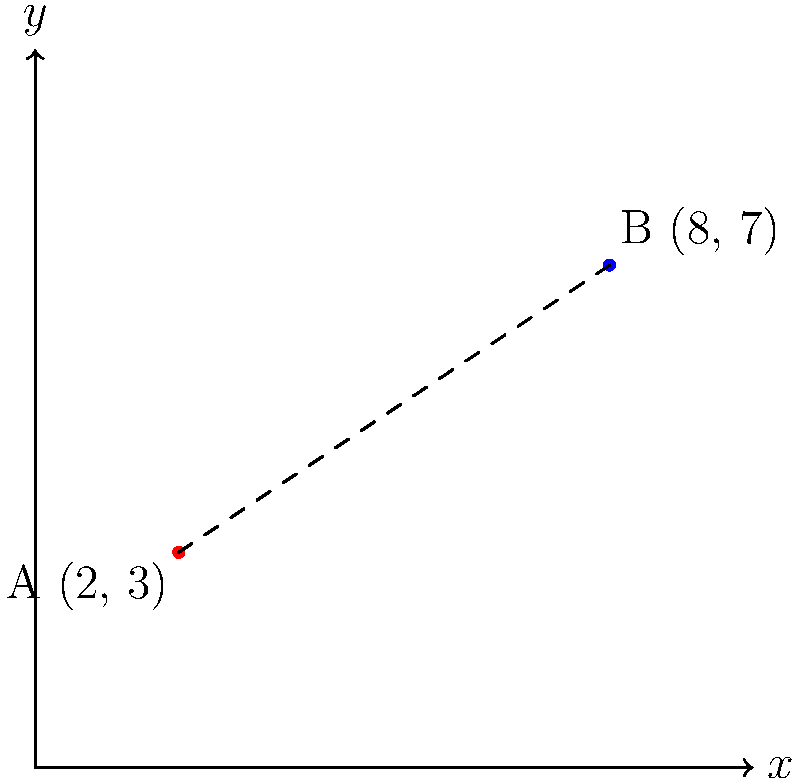As a classic car enthusiast, you're planning to visit two renowned dealerships specializing in vintage automobiles. Dealership A is located at coordinates (2, 3) and Dealership B is at (8, 7) on a city map grid. What is the straight-line distance between these two classic car dealerships? To find the distance between two points on a coordinate plane, we can use the distance formula, which is derived from the Pythagorean theorem:

$$d = \sqrt{(x_2 - x_1)^2 + (y_2 - y_1)^2}$$

Where $(x_1, y_1)$ are the coordinates of the first point and $(x_2, y_2)$ are the coordinates of the second point.

Let's plug in our values:
* Point A (Dealership A): $(x_1, y_1) = (2, 3)$
* Point B (Dealership B): $(x_2, y_2) = (8, 7)$

Now, let's calculate:

1) $d = \sqrt{(8 - 2)^2 + (7 - 3)^2}$

2) $d = \sqrt{6^2 + 4^2}$

3) $d = \sqrt{36 + 16}$

4) $d = \sqrt{52}$

5) $d = 2\sqrt{13}$ (simplified)

Therefore, the straight-line distance between the two classic car dealerships is $2\sqrt{13}$ units.
Answer: $2\sqrt{13}$ units 